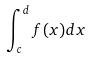Convert formula to latex. <formula><loc_0><loc_0><loc_500><loc_500>\int _ { c } ^ { d } f ( x ) d x</formula> 